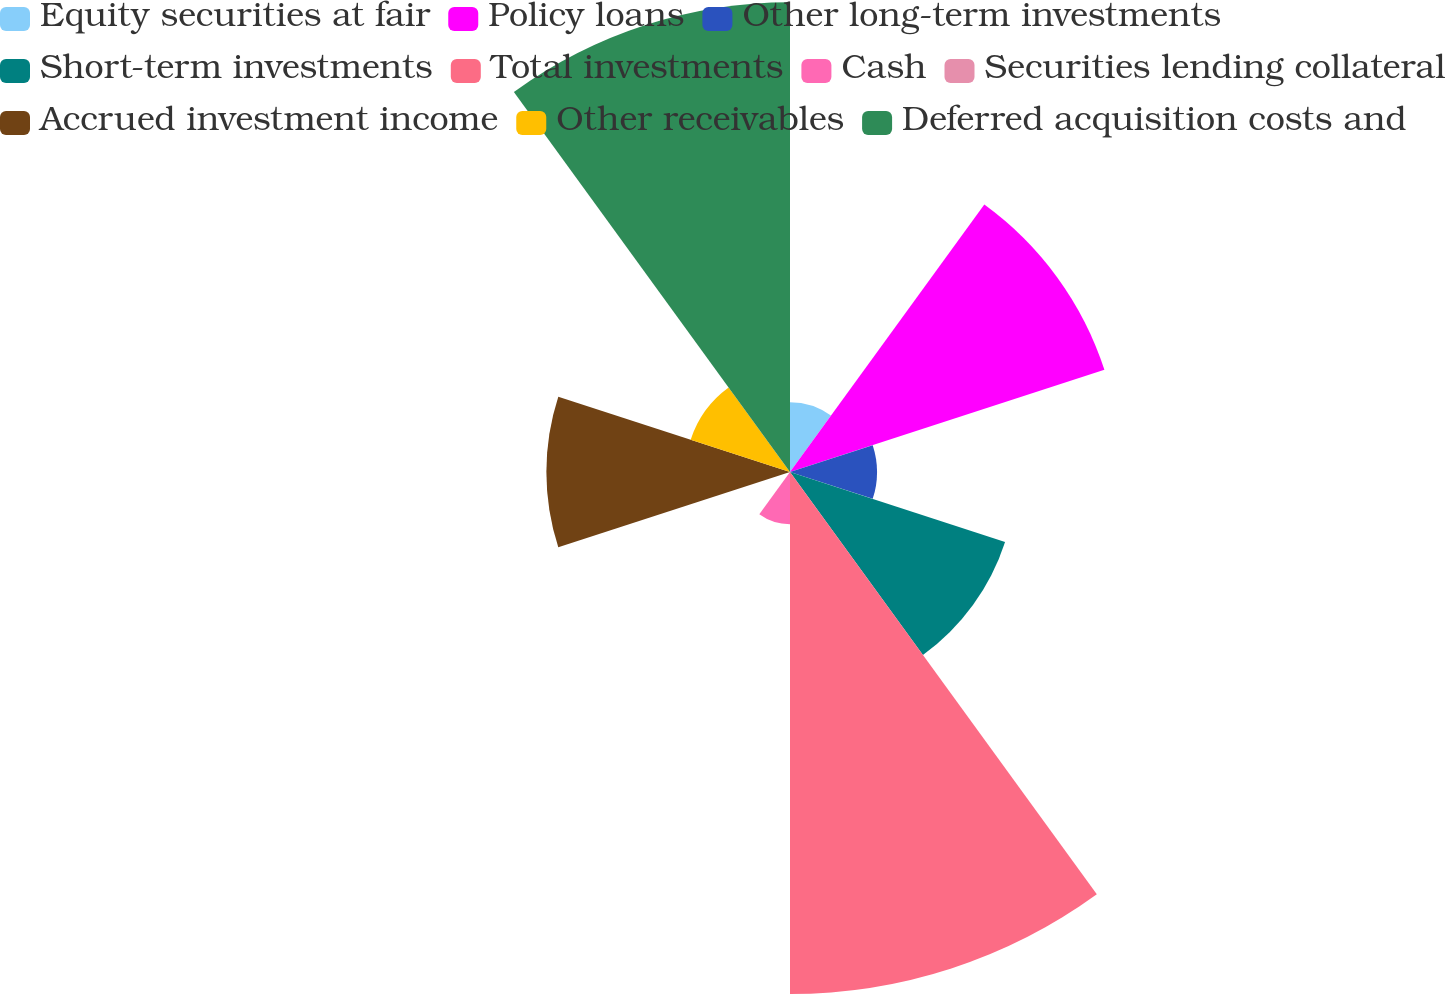Convert chart to OTSL. <chart><loc_0><loc_0><loc_500><loc_500><pie_chart><fcel>Equity securities at fair<fcel>Policy loans<fcel>Other long-term investments<fcel>Short-term investments<fcel>Total investments<fcel>Cash<fcel>Securities lending collateral<fcel>Accrued investment income<fcel>Other receivables<fcel>Deferred acquisition costs and<nl><fcel>3.31%<fcel>15.7%<fcel>4.13%<fcel>10.74%<fcel>24.79%<fcel>2.48%<fcel>0.0%<fcel>11.57%<fcel>4.96%<fcel>22.31%<nl></chart> 